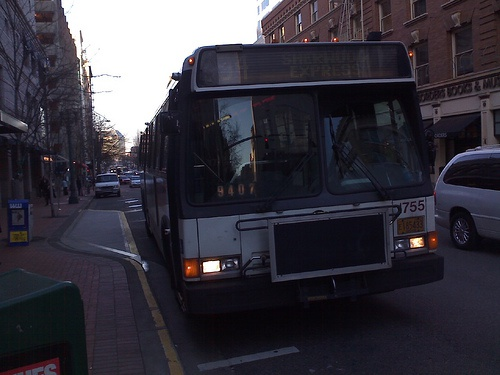Describe the objects in this image and their specific colors. I can see bus in black, gray, and darkblue tones, car in black, purple, and navy tones, people in black tones, car in black and gray tones, and people in black tones in this image. 